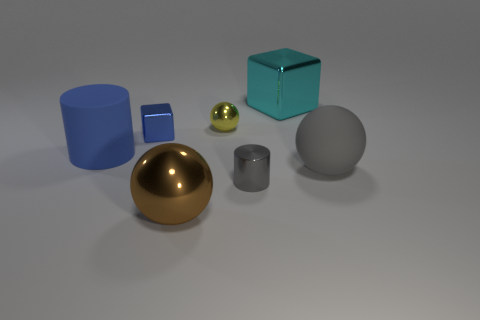What is the color of the big block behind the gray metallic thing that is in front of the yellow sphere? cyan 